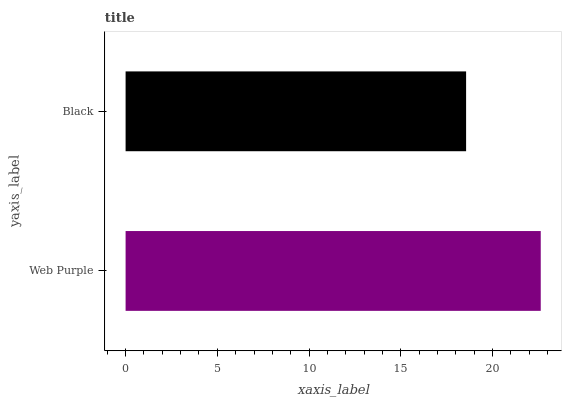Is Black the minimum?
Answer yes or no. Yes. Is Web Purple the maximum?
Answer yes or no. Yes. Is Black the maximum?
Answer yes or no. No. Is Web Purple greater than Black?
Answer yes or no. Yes. Is Black less than Web Purple?
Answer yes or no. Yes. Is Black greater than Web Purple?
Answer yes or no. No. Is Web Purple less than Black?
Answer yes or no. No. Is Web Purple the high median?
Answer yes or no. Yes. Is Black the low median?
Answer yes or no. Yes. Is Black the high median?
Answer yes or no. No. Is Web Purple the low median?
Answer yes or no. No. 